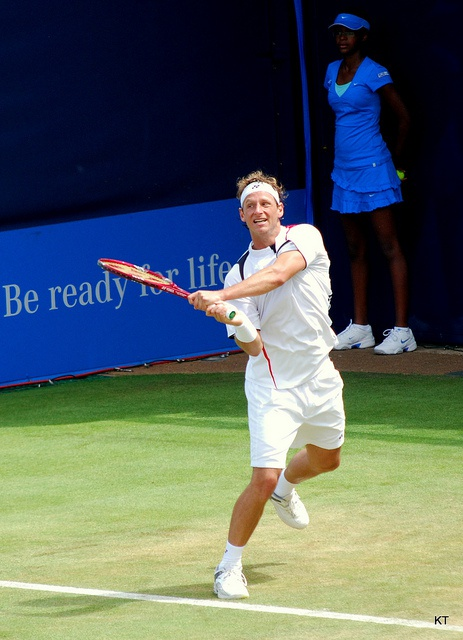Describe the objects in this image and their specific colors. I can see people in navy, lightgray, darkgray, and brown tones, people in navy, black, blue, and darkblue tones, and tennis racket in navy, darkblue, khaki, lightpink, and brown tones in this image. 